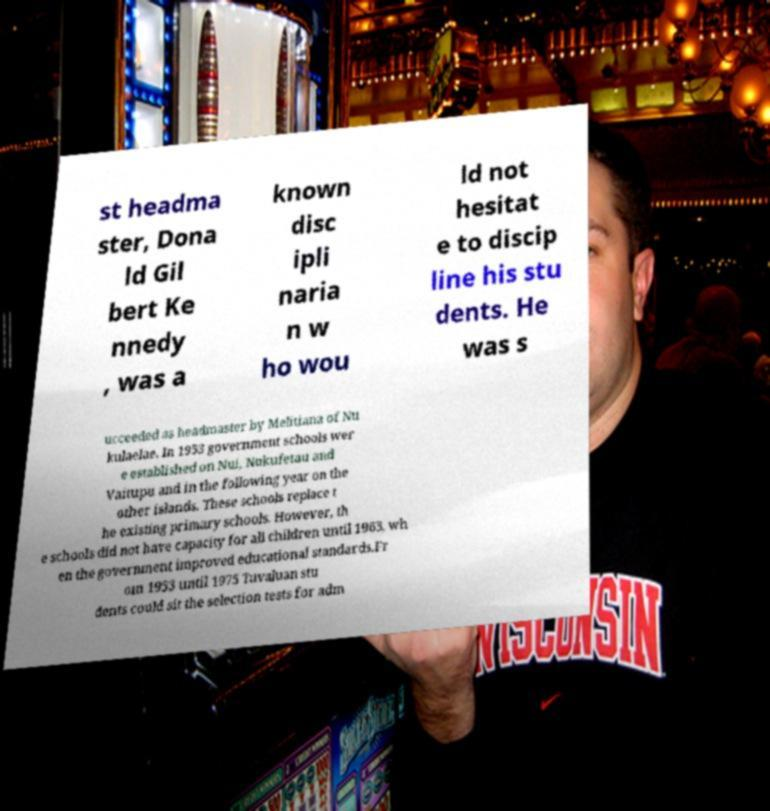There's text embedded in this image that I need extracted. Can you transcribe it verbatim? st headma ster, Dona ld Gil bert Ke nnedy , was a known disc ipli naria n w ho wou ld not hesitat e to discip line his stu dents. He was s ucceeded as headmaster by Melitiana of Nu kulaelae. In 1953 government schools wer e established on Nui, Nukufetau and Vaitupu and in the following year on the other islands. These schools replace t he existing primary schools. However, th e schools did not have capacity for all children until 1963, wh en the government improved educational standards.Fr om 1953 until 1975 Tuvaluan stu dents could sit the selection tests for adm 